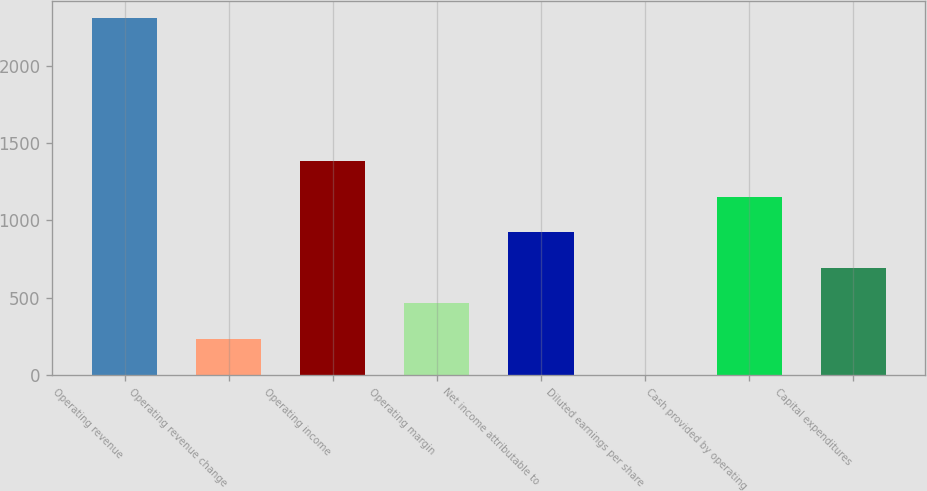Convert chart to OTSL. <chart><loc_0><loc_0><loc_500><loc_500><bar_chart><fcel>Operating revenue<fcel>Operating revenue change<fcel>Operating income<fcel>Operating margin<fcel>Net income attributable to<fcel>Diluted earnings per share<fcel>Cash provided by operating<fcel>Capital expenditures<nl><fcel>2303.9<fcel>232.81<fcel>1383.41<fcel>462.93<fcel>923.17<fcel>2.69<fcel>1153.29<fcel>693.05<nl></chart> 